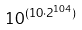<formula> <loc_0><loc_0><loc_500><loc_500>1 0 ^ { ( 1 0 \cdot 2 ^ { 1 0 4 } ) }</formula> 